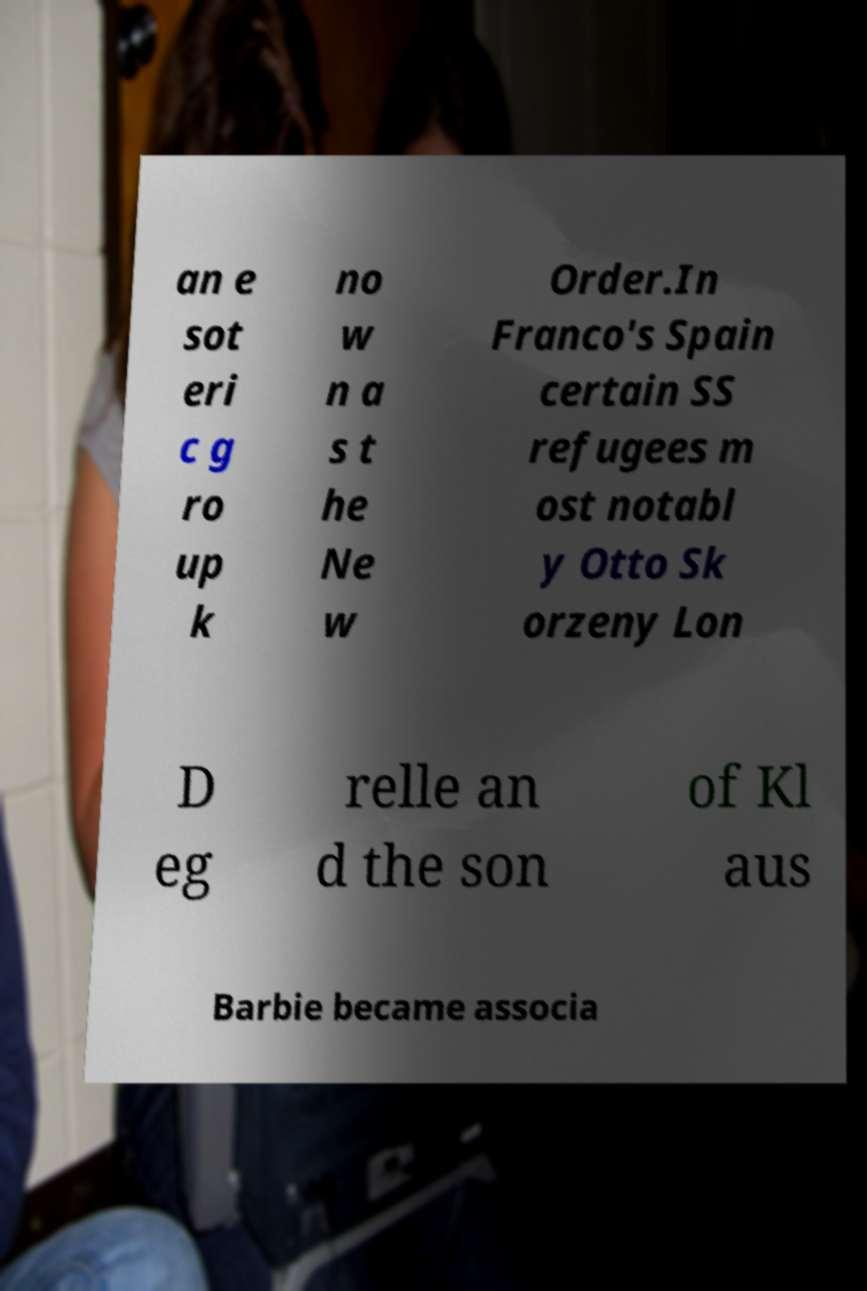Could you extract and type out the text from this image? an e sot eri c g ro up k no w n a s t he Ne w Order.In Franco's Spain certain SS refugees m ost notabl y Otto Sk orzeny Lon D eg relle an d the son of Kl aus Barbie became associa 